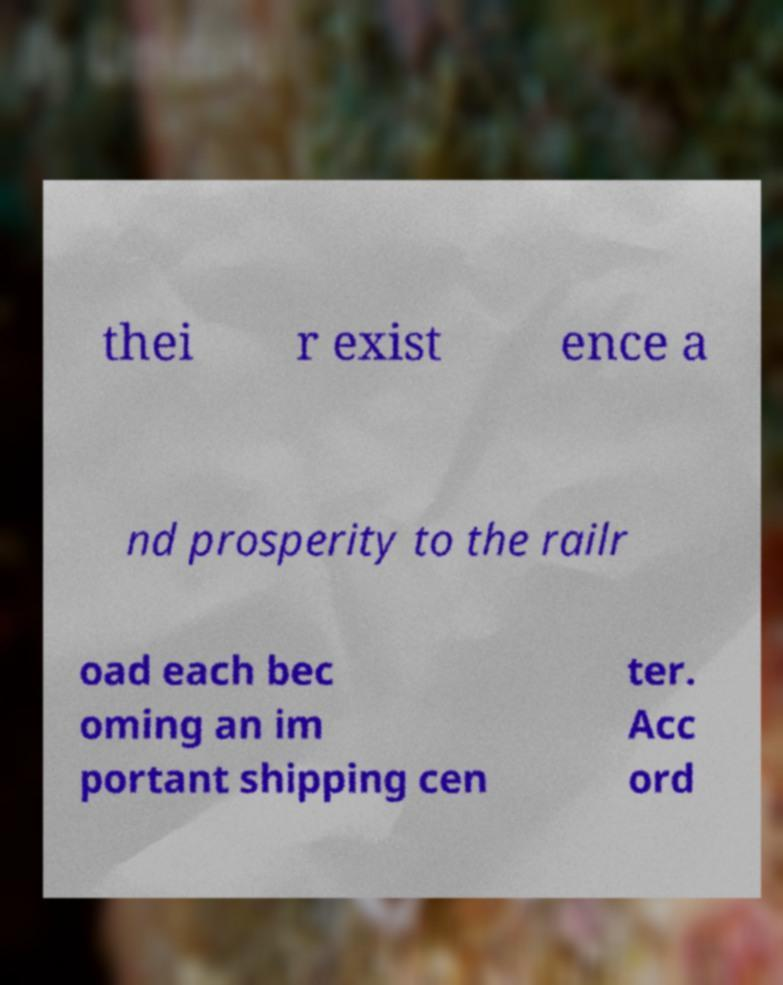Can you read and provide the text displayed in the image?This photo seems to have some interesting text. Can you extract and type it out for me? thei r exist ence a nd prosperity to the railr oad each bec oming an im portant shipping cen ter. Acc ord 